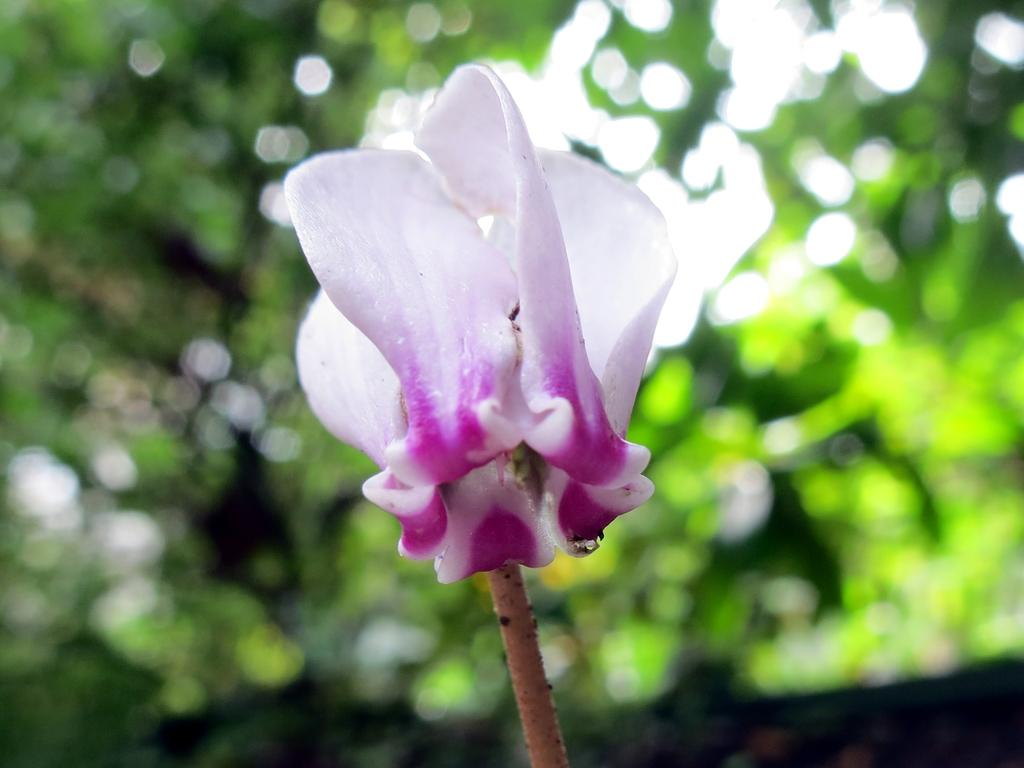What is the main subject of the image? There is a flower in the image. Can you describe the background of the image? The background of the image is blurred. How many friends are playing basketball in the image? There are no friends or basketball present in the image; it features a flower and a blurred background. What type of pencil can be seen drawing the flower in the image? There is no pencil or drawing activity depicted in the image; it simply shows a flower and a blurred background. 